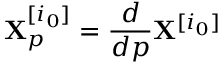<formula> <loc_0><loc_0><loc_500><loc_500>X _ { p } ^ { [ i _ { 0 } ] } = \frac { d } { d p } X ^ { [ i _ { 0 } ] }</formula> 